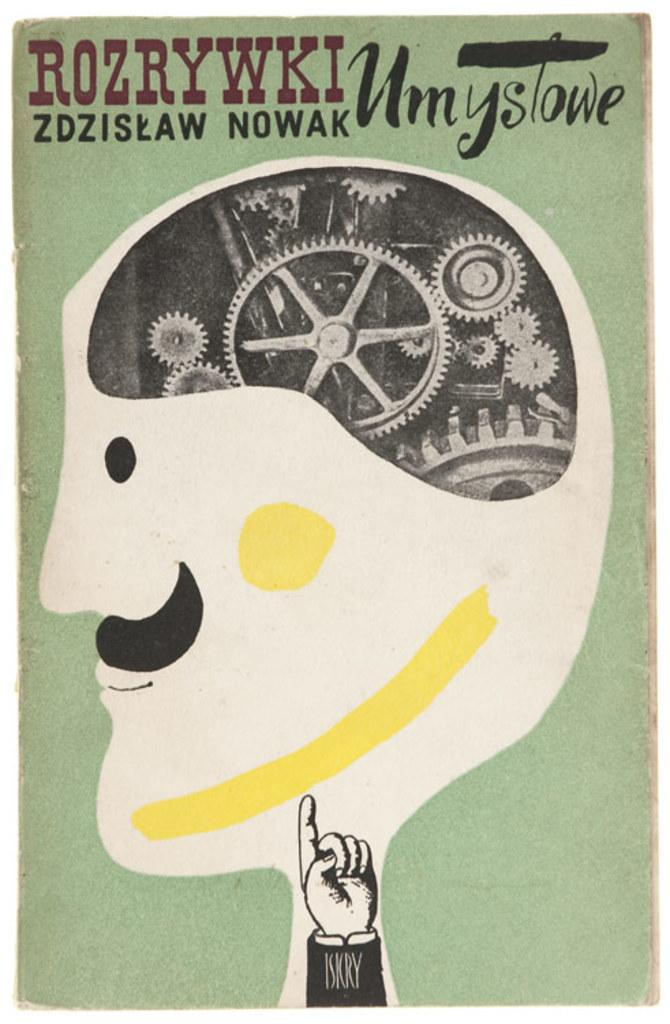<image>
Render a clear and concise summary of the photo. An image of a mustached man with gears in his head is printed with "Rozrywki zdziskaw Nowak" and "Umystowe". 